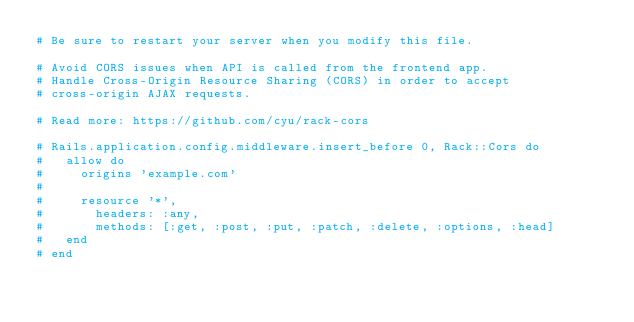<code> <loc_0><loc_0><loc_500><loc_500><_Ruby_># Be sure to restart your server when you modify this file.

# Avoid CORS issues when API is called from the frontend app.
# Handle Cross-Origin Resource Sharing (CORS) in order to accept
# cross-origin AJAX requests.

# Read more: https://github.com/cyu/rack-cors

# Rails.application.config.middleware.insert_before 0, Rack::Cors do
#   allow do
#     origins 'example.com'
#
#     resource '*',
#       headers: :any,
#       methods: [:get, :post, :put, :patch, :delete, :options, :head]
#   end
# end
</code> 